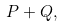Convert formula to latex. <formula><loc_0><loc_0><loc_500><loc_500>P + Q ,</formula> 